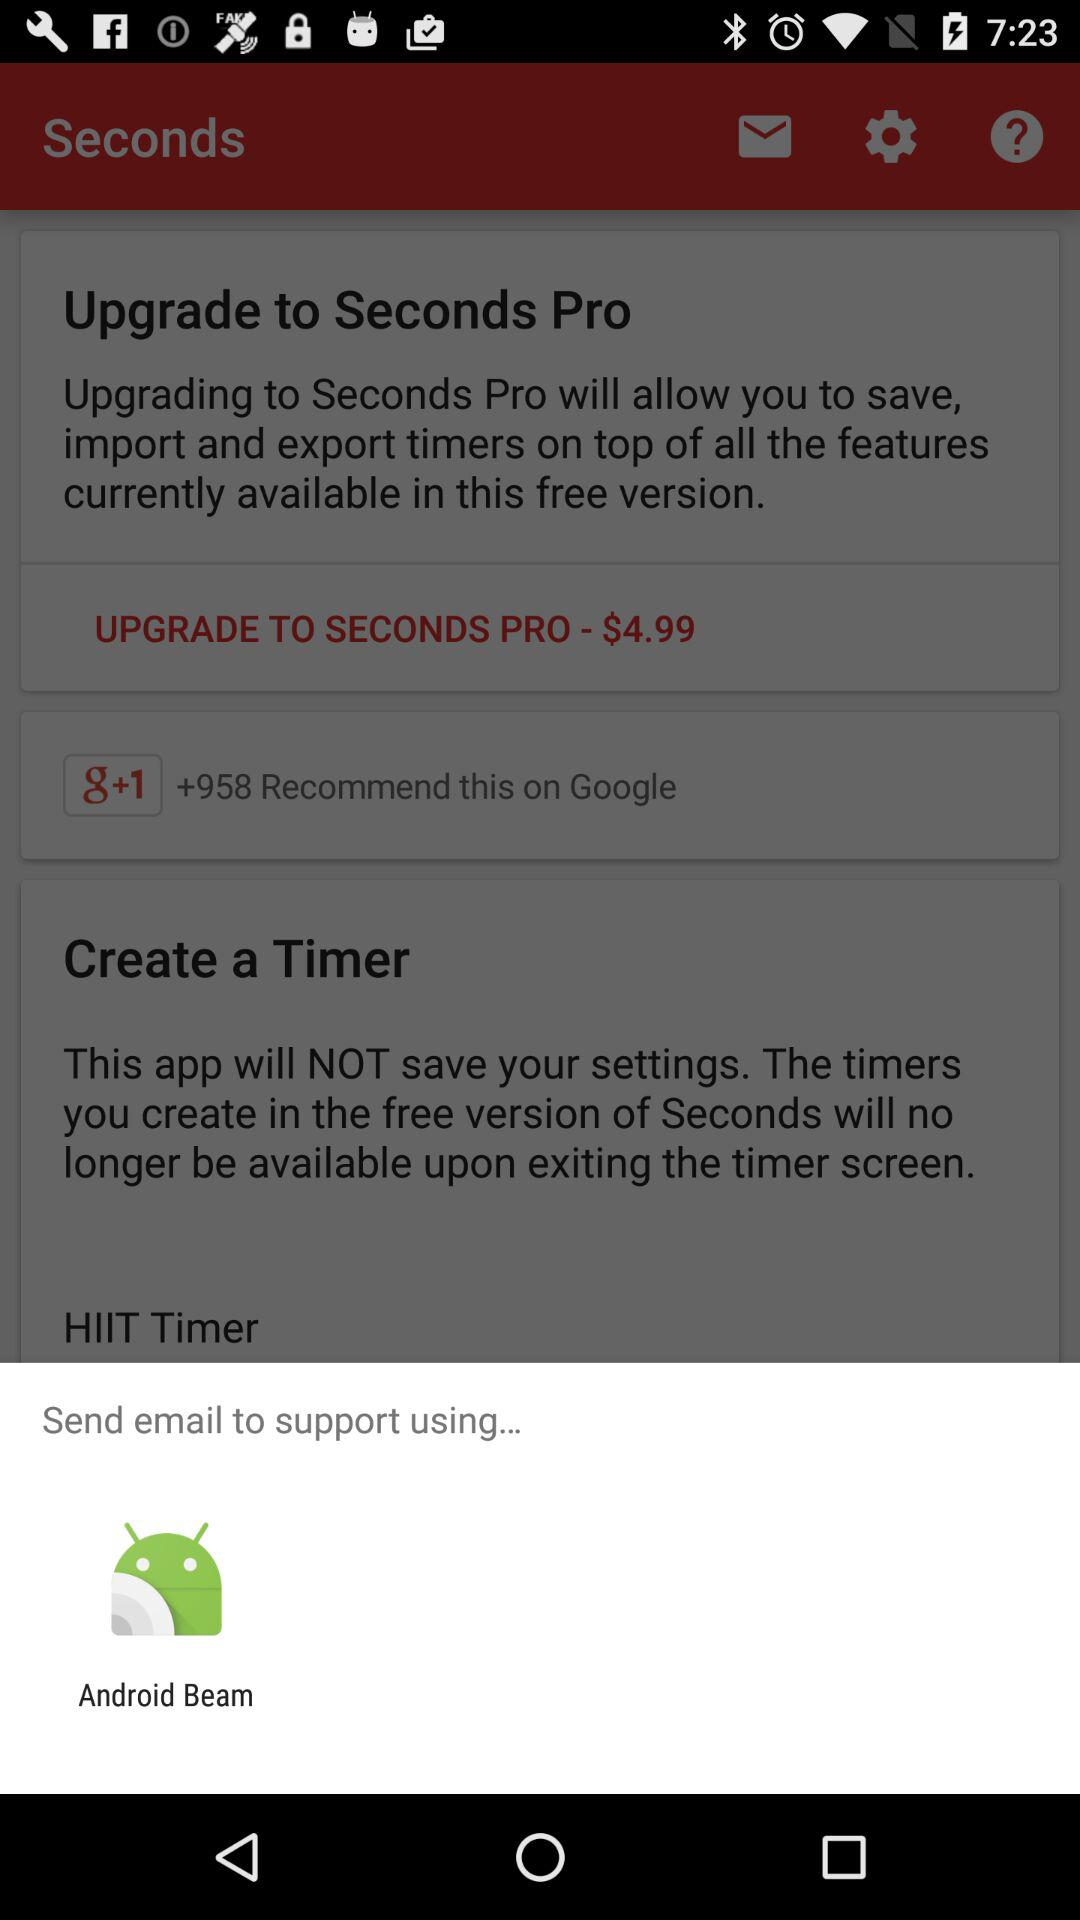What is the cost of upgrading to "SECONDS PRO"? The cost of upgrading to "SECONDS PRO" is $4.99. 